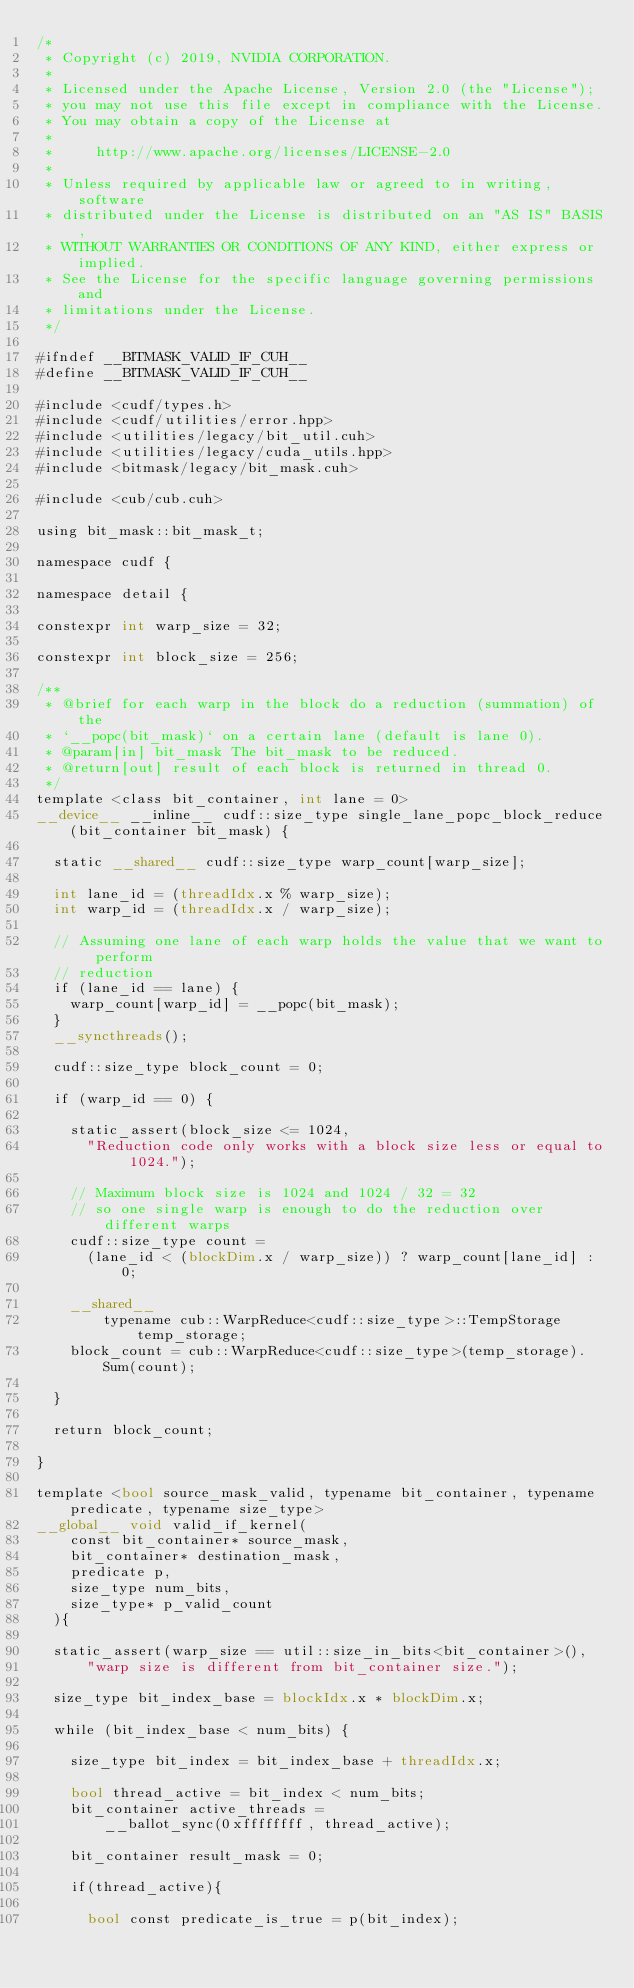<code> <loc_0><loc_0><loc_500><loc_500><_Cuda_>/*
 * Copyright (c) 2019, NVIDIA CORPORATION.
 *
 * Licensed under the Apache License, Version 2.0 (the "License");
 * you may not use this file except in compliance with the License.
 * You may obtain a copy of the License at
 *
 *     http://www.apache.org/licenses/LICENSE-2.0
 *
 * Unless required by applicable law or agreed to in writing, software
 * distributed under the License is distributed on an "AS IS" BASIS,
 * WITHOUT WARRANTIES OR CONDITIONS OF ANY KIND, either express or implied.
 * See the License for the specific language governing permissions and
 * limitations under the License.
 */ 

#ifndef __BITMASK_VALID_IF_CUH__
#define __BITMASK_VALID_IF_CUH__

#include <cudf/types.h>
#include <cudf/utilities/error.hpp>
#include <utilities/legacy/bit_util.cuh>
#include <utilities/legacy/cuda_utils.hpp>
#include <bitmask/legacy/bit_mask.cuh>

#include <cub/cub.cuh>

using bit_mask::bit_mask_t;

namespace cudf {

namespace detail {

constexpr int warp_size = 32;

constexpr int block_size = 256;

/**
 * @brief for each warp in the block do a reduction (summation) of the
 * `__popc(bit_mask)` on a certain lane (default is lane 0).
 * @param[in] bit_mask The bit_mask to be reduced.
 * @return[out] result of each block is returned in thread 0.
 */
template <class bit_container, int lane = 0>
__device__ __inline__ cudf::size_type single_lane_popc_block_reduce(bit_container bit_mask) {
  
  static __shared__ cudf::size_type warp_count[warp_size];
  
  int lane_id = (threadIdx.x % warp_size);
  int warp_id = (threadIdx.x / warp_size);

  // Assuming one lane of each warp holds the value that we want to perform
  // reduction
  if (lane_id == lane) {
    warp_count[warp_id] = __popc(bit_mask);
  }
  __syncthreads();

  cudf::size_type block_count = 0;

  if (warp_id == 0) {
    
    static_assert(block_size <= 1024,
      "Reduction code only works with a block size less or equal to 1024.");

    // Maximum block size is 1024 and 1024 / 32 = 32
    // so one single warp is enough to do the reduction over different warps
    cudf::size_type count = 
      (lane_id < (blockDim.x / warp_size)) ? warp_count[lane_id] : 0;
    
    __shared__
        typename cub::WarpReduce<cudf::size_type>::TempStorage temp_storage;
    block_count = cub::WarpReduce<cudf::size_type>(temp_storage).Sum(count);

  }

  return block_count;

}

template <bool source_mask_valid, typename bit_container, typename predicate, typename size_type>
__global__ void valid_if_kernel(
    const bit_container* source_mask, 
    bit_container* destination_mask, 
    predicate p,
    size_type num_bits,
    size_type* p_valid_count
  ){
 
  static_assert(warp_size == util::size_in_bits<bit_container>(), 
      "warp size is different from bit_container size.");

  size_type bit_index_base = blockIdx.x * blockDim.x;

  while (bit_index_base < num_bits) {
  
    size_type bit_index = bit_index_base + threadIdx.x;
   
    bool thread_active = bit_index < num_bits;
    bit_container active_threads =
        __ballot_sync(0xffffffff, thread_active);

    bit_container result_mask = 0;

    if(thread_active){
      
      bool const predicate_is_true = p(bit_index);</code> 